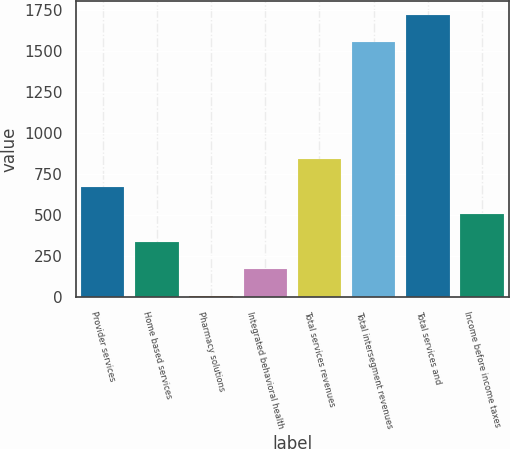<chart> <loc_0><loc_0><loc_500><loc_500><bar_chart><fcel>Provider services<fcel>Home based services<fcel>Pharmacy solutions<fcel>Integrated behavioral health<fcel>Total services revenues<fcel>Total intersegment revenues<fcel>Total services and<fcel>Income before income taxes<nl><fcel>672.6<fcel>338.8<fcel>5<fcel>171.9<fcel>839.5<fcel>1553<fcel>1719.9<fcel>505.7<nl></chart> 